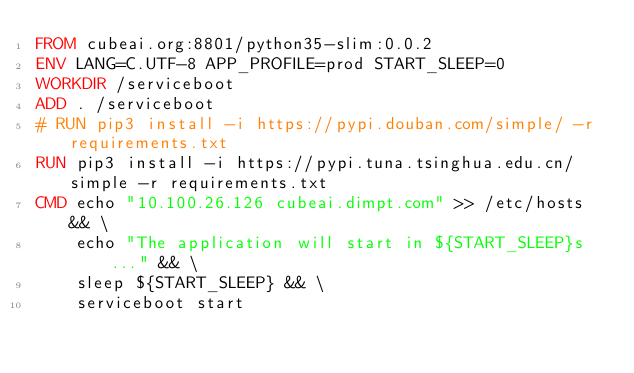<code> <loc_0><loc_0><loc_500><loc_500><_Dockerfile_>FROM cubeai.org:8801/python35-slim:0.0.2
ENV LANG=C.UTF-8 APP_PROFILE=prod START_SLEEP=0
WORKDIR /serviceboot
ADD . /serviceboot
# RUN pip3 install -i https://pypi.douban.com/simple/ -r requirements.txt
RUN pip3 install -i https://pypi.tuna.tsinghua.edu.cn/simple -r requirements.txt
CMD echo "10.100.26.126 cubeai.dimpt.com" >> /etc/hosts && \
    echo "The application will start in ${START_SLEEP}s..." && \
    sleep ${START_SLEEP} && \
    serviceboot start
</code> 